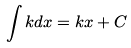Convert formula to latex. <formula><loc_0><loc_0><loc_500><loc_500>\int k d x = k x + C</formula> 